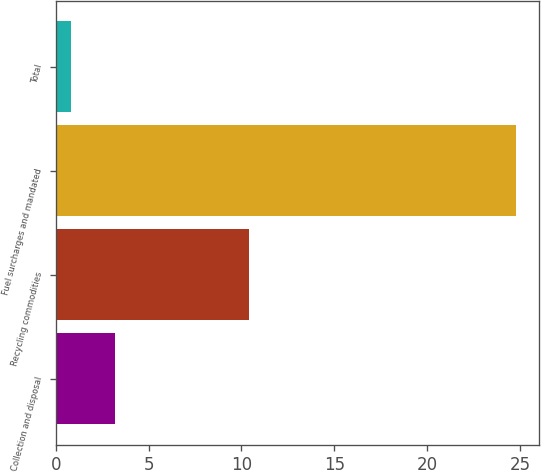Convert chart. <chart><loc_0><loc_0><loc_500><loc_500><bar_chart><fcel>Collection and disposal<fcel>Recycling commodities<fcel>Fuel surcharges and mandated<fcel>Total<nl><fcel>3.2<fcel>10.4<fcel>24.8<fcel>0.8<nl></chart> 